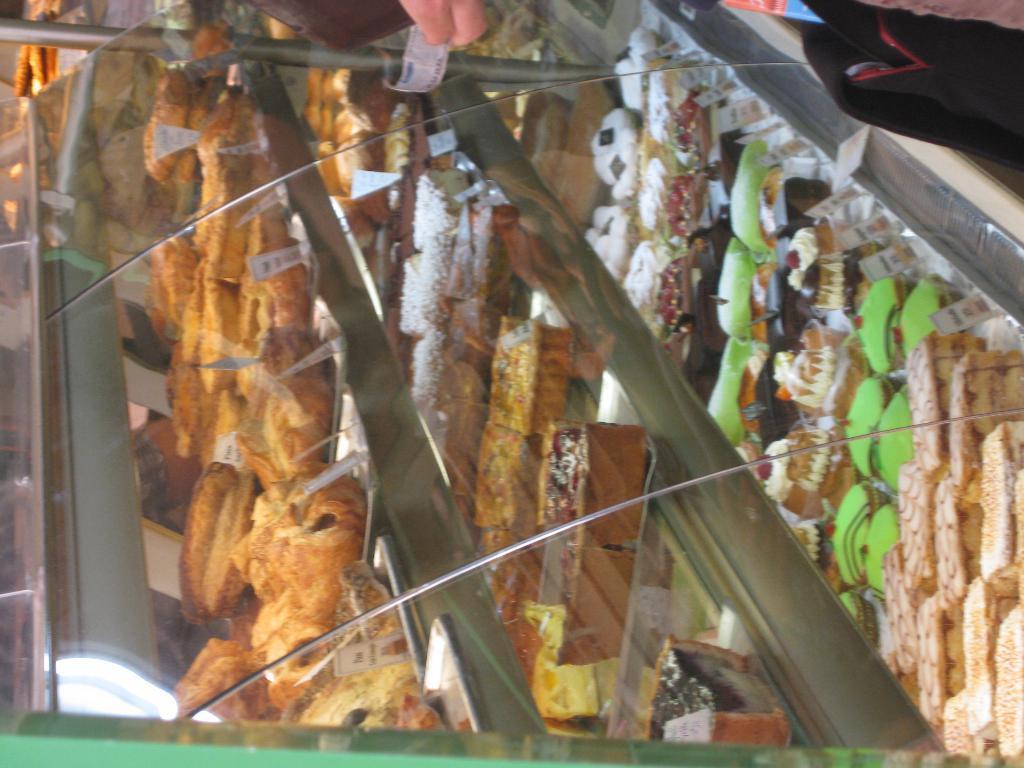Describe this image in one or two sentences. In this image we can see there is a glass shelf with some food items. 